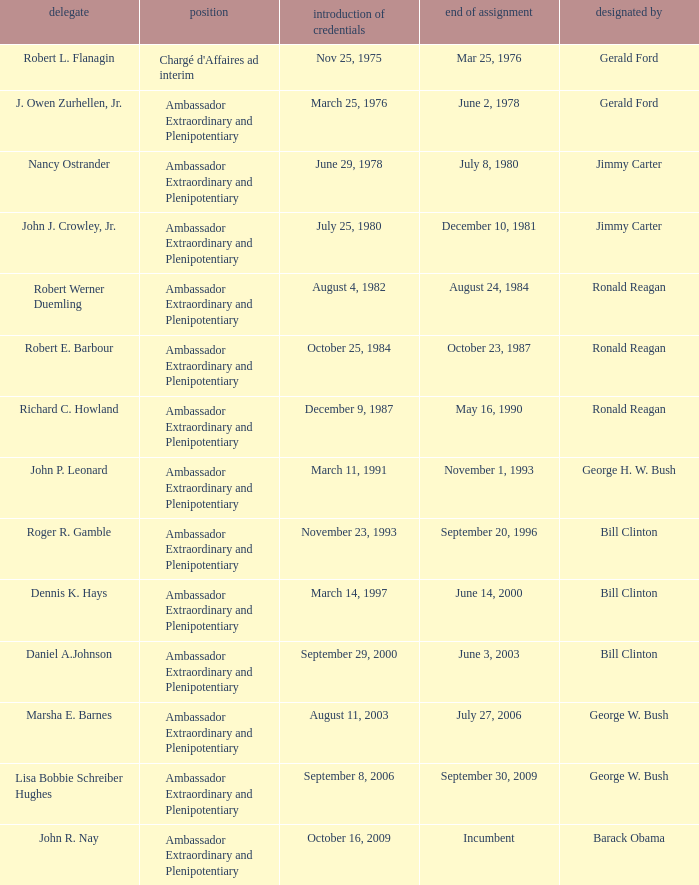Would you be able to parse every entry in this table? {'header': ['delegate', 'position', 'introduction of credentials', 'end of assignment', 'designated by'], 'rows': [['Robert L. Flanagin', "Chargé d'Affaires ad interim", 'Nov 25, 1975', 'Mar 25, 1976', 'Gerald Ford'], ['J. Owen Zurhellen, Jr.', 'Ambassador Extraordinary and Plenipotentiary', 'March 25, 1976', 'June 2, 1978', 'Gerald Ford'], ['Nancy Ostrander', 'Ambassador Extraordinary and Plenipotentiary', 'June 29, 1978', 'July 8, 1980', 'Jimmy Carter'], ['John J. Crowley, Jr.', 'Ambassador Extraordinary and Plenipotentiary', 'July 25, 1980', 'December 10, 1981', 'Jimmy Carter'], ['Robert Werner Duemling', 'Ambassador Extraordinary and Plenipotentiary', 'August 4, 1982', 'August 24, 1984', 'Ronald Reagan'], ['Robert E. Barbour', 'Ambassador Extraordinary and Plenipotentiary', 'October 25, 1984', 'October 23, 1987', 'Ronald Reagan'], ['Richard C. Howland', 'Ambassador Extraordinary and Plenipotentiary', 'December 9, 1987', 'May 16, 1990', 'Ronald Reagan'], ['John P. Leonard', 'Ambassador Extraordinary and Plenipotentiary', 'March 11, 1991', 'November 1, 1993', 'George H. W. Bush'], ['Roger R. Gamble', 'Ambassador Extraordinary and Plenipotentiary', 'November 23, 1993', 'September 20, 1996', 'Bill Clinton'], ['Dennis K. Hays', 'Ambassador Extraordinary and Plenipotentiary', 'March 14, 1997', 'June 14, 2000', 'Bill Clinton'], ['Daniel A.Johnson', 'Ambassador Extraordinary and Plenipotentiary', 'September 29, 2000', 'June 3, 2003', 'Bill Clinton'], ['Marsha E. Barnes', 'Ambassador Extraordinary and Plenipotentiary', 'August 11, 2003', 'July 27, 2006', 'George W. Bush'], ['Lisa Bobbie Schreiber Hughes', 'Ambassador Extraordinary and Plenipotentiary', 'September 8, 2006', 'September 30, 2009', 'George W. Bush'], ['John R. Nay', 'Ambassador Extraordinary and Plenipotentiary', 'October 16, 2009', 'Incumbent', 'Barack Obama']]} Which representative has a Termination of MIssion date Mar 25, 1976? Robert L. Flanagin. 